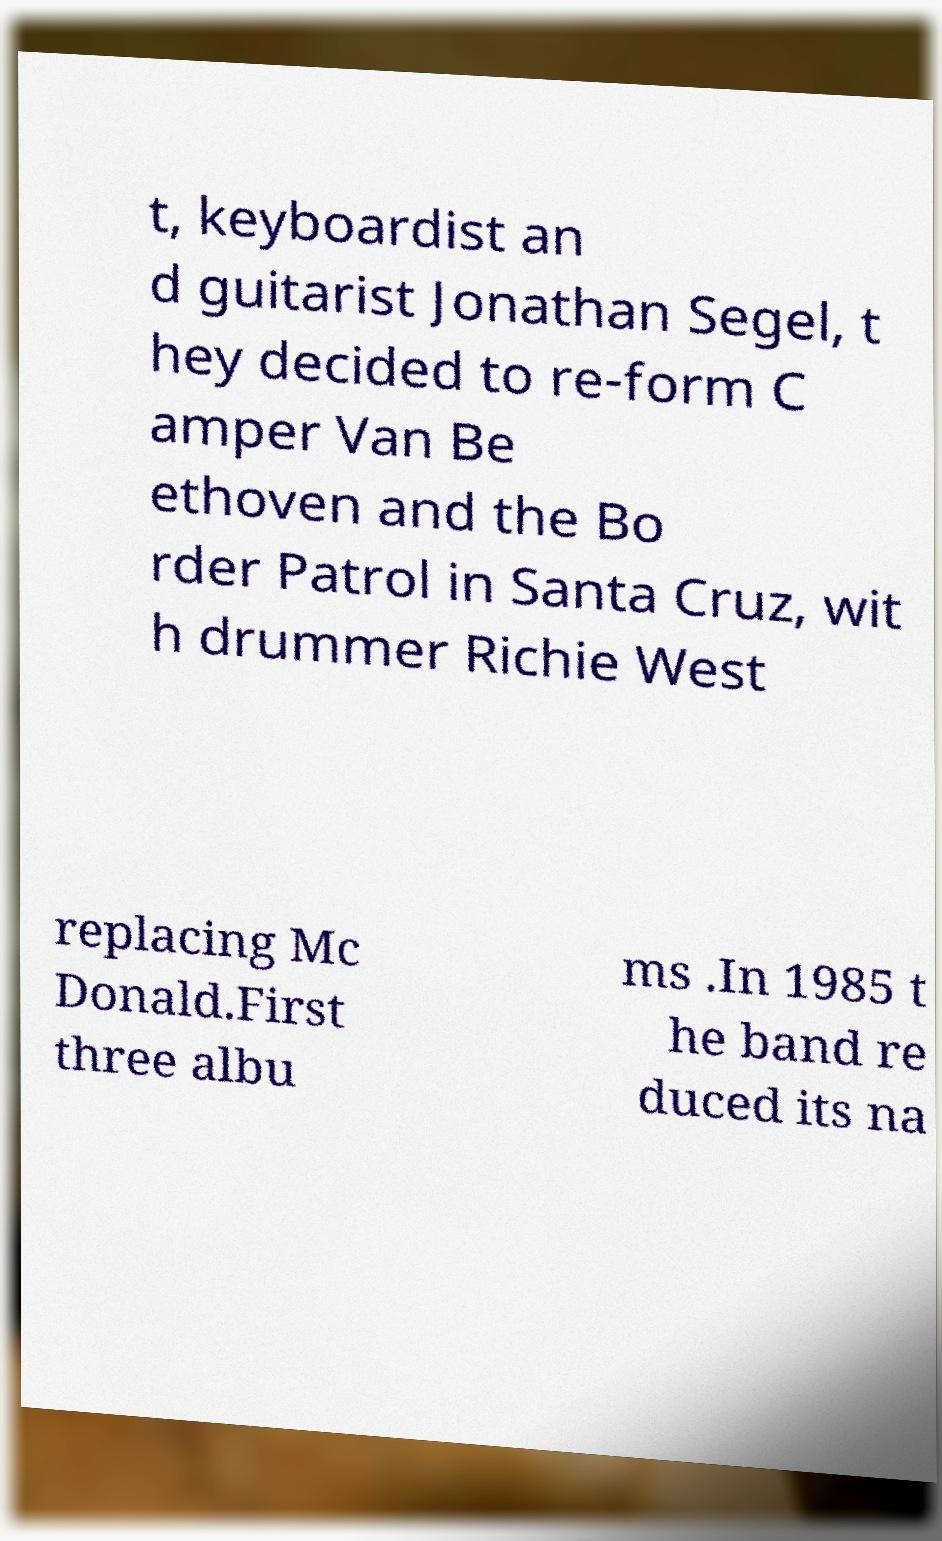I need the written content from this picture converted into text. Can you do that? t, keyboardist an d guitarist Jonathan Segel, t hey decided to re-form C amper Van Be ethoven and the Bo rder Patrol in Santa Cruz, wit h drummer Richie West replacing Mc Donald.First three albu ms .In 1985 t he band re duced its na 